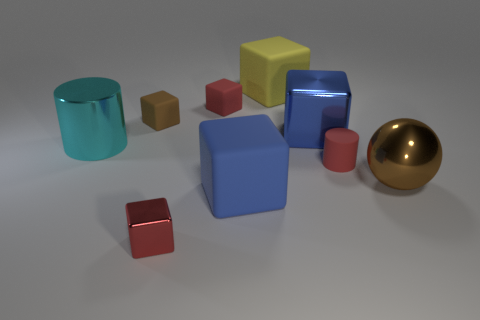Add 1 tiny brown objects. How many objects exist? 10 Subtract all big blue metal blocks. How many blocks are left? 5 Subtract all cubes. How many objects are left? 3 Subtract 6 blocks. How many blocks are left? 0 Subtract all gray cylinders. Subtract all green cubes. How many cylinders are left? 2 Subtract all blue cylinders. How many cyan blocks are left? 0 Subtract all big blue blocks. Subtract all red matte blocks. How many objects are left? 6 Add 2 blue rubber objects. How many blue rubber objects are left? 3 Add 2 shiny blocks. How many shiny blocks exist? 4 Subtract all cyan cylinders. How many cylinders are left? 1 